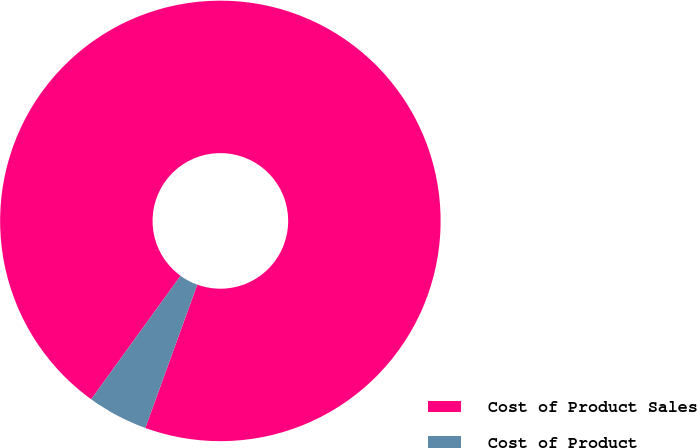<chart> <loc_0><loc_0><loc_500><loc_500><pie_chart><fcel>Cost of Product Sales<fcel>Cost of Product<nl><fcel>95.56%<fcel>4.44%<nl></chart> 